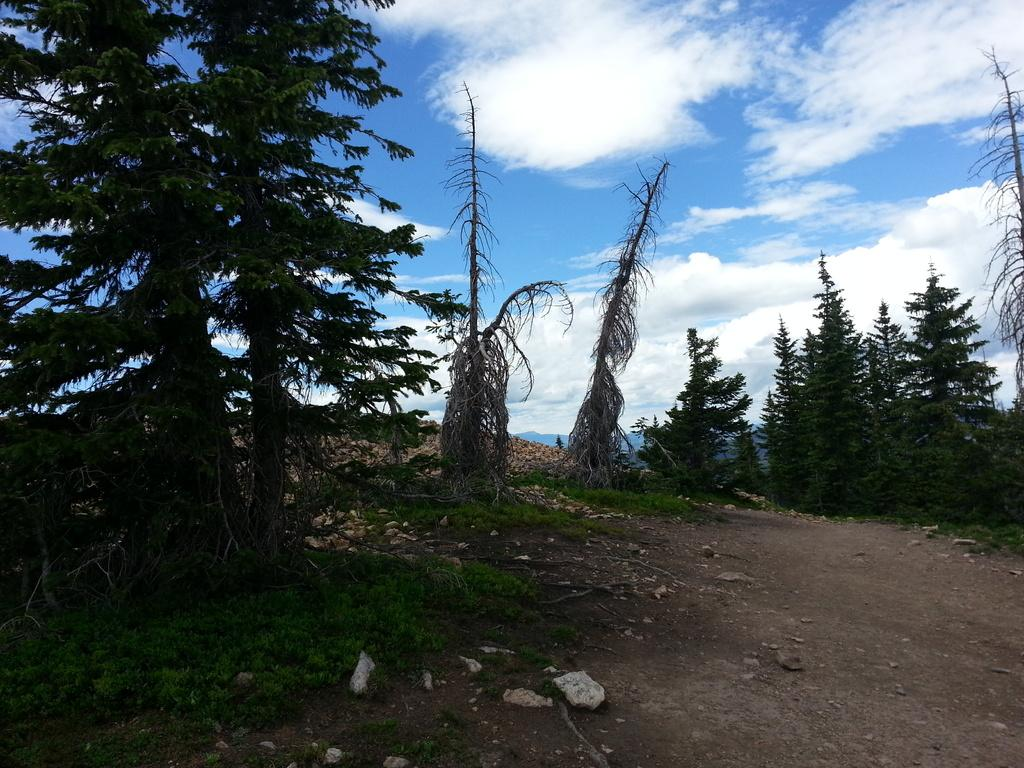What type of vegetation can be seen on the right side of the image? There are trees on the right side of the image. What type of vegetation can be seen on the left side of the image? There are trees on the left side of the image. How many robins are perched on the trees in the image? There are no robins present in the image; it only features trees. 